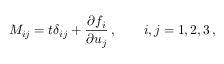Convert formula to latex. <formula><loc_0><loc_0><loc_500><loc_500>M _ { i j } = t \delta _ { i j } + \frac { \partial f _ { i } } { \partial u _ { j } } \, , \quad i , j = 1 , 2 , 3 \, ,</formula> 